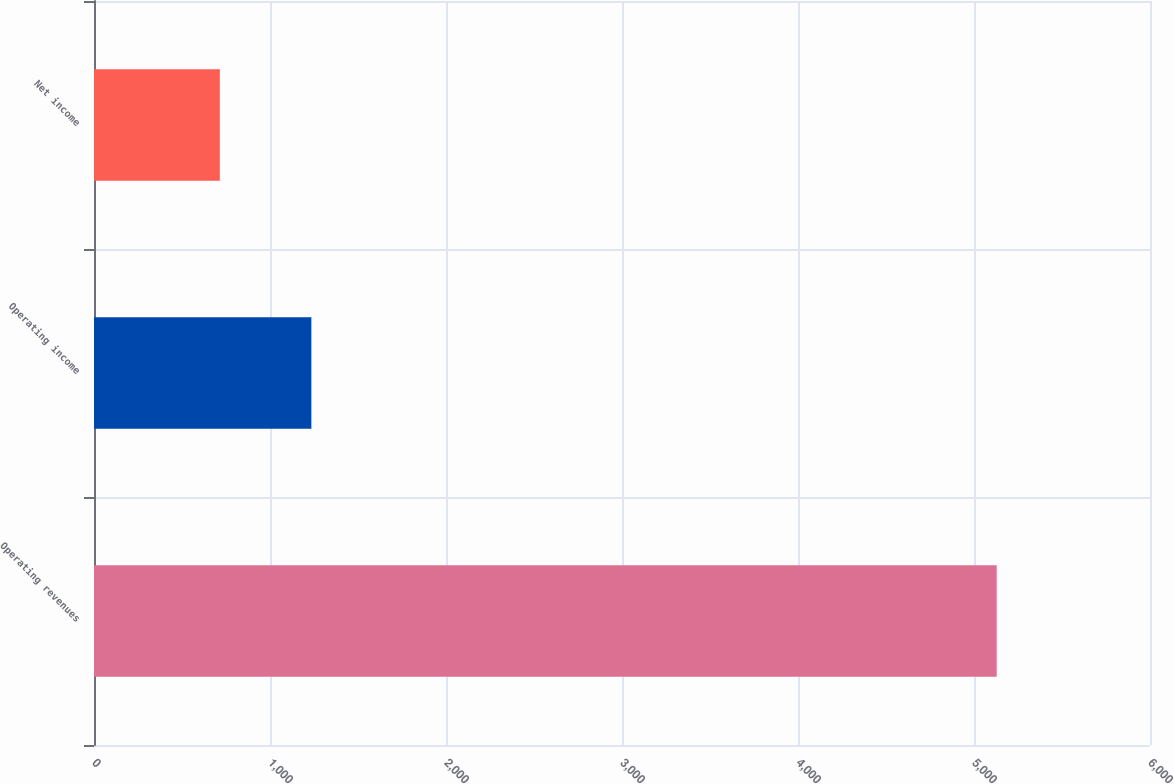<chart> <loc_0><loc_0><loc_500><loc_500><bar_chart><fcel>Operating revenues<fcel>Operating income<fcel>Net income<nl><fcel>5129<fcel>1235<fcel>715<nl></chart> 